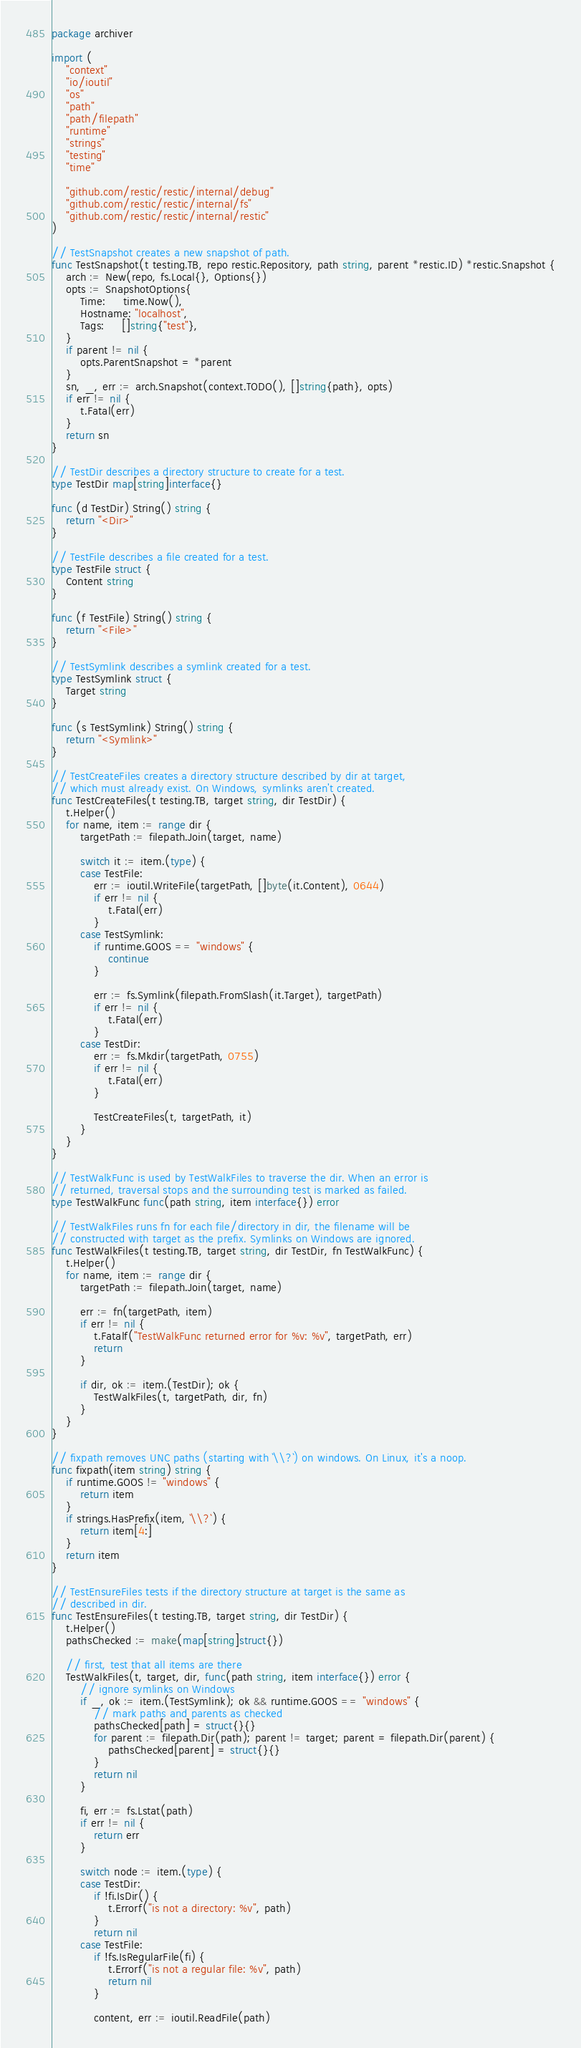<code> <loc_0><loc_0><loc_500><loc_500><_Go_>package archiver

import (
	"context"
	"io/ioutil"
	"os"
	"path"
	"path/filepath"
	"runtime"
	"strings"
	"testing"
	"time"

	"github.com/restic/restic/internal/debug"
	"github.com/restic/restic/internal/fs"
	"github.com/restic/restic/internal/restic"
)

// TestSnapshot creates a new snapshot of path.
func TestSnapshot(t testing.TB, repo restic.Repository, path string, parent *restic.ID) *restic.Snapshot {
	arch := New(repo, fs.Local{}, Options{})
	opts := SnapshotOptions{
		Time:     time.Now(),
		Hostname: "localhost",
		Tags:     []string{"test"},
	}
	if parent != nil {
		opts.ParentSnapshot = *parent
	}
	sn, _, err := arch.Snapshot(context.TODO(), []string{path}, opts)
	if err != nil {
		t.Fatal(err)
	}
	return sn
}

// TestDir describes a directory structure to create for a test.
type TestDir map[string]interface{}

func (d TestDir) String() string {
	return "<Dir>"
}

// TestFile describes a file created for a test.
type TestFile struct {
	Content string
}

func (f TestFile) String() string {
	return "<File>"
}

// TestSymlink describes a symlink created for a test.
type TestSymlink struct {
	Target string
}

func (s TestSymlink) String() string {
	return "<Symlink>"
}

// TestCreateFiles creates a directory structure described by dir at target,
// which must already exist. On Windows, symlinks aren't created.
func TestCreateFiles(t testing.TB, target string, dir TestDir) {
	t.Helper()
	for name, item := range dir {
		targetPath := filepath.Join(target, name)

		switch it := item.(type) {
		case TestFile:
			err := ioutil.WriteFile(targetPath, []byte(it.Content), 0644)
			if err != nil {
				t.Fatal(err)
			}
		case TestSymlink:
			if runtime.GOOS == "windows" {
				continue
			}

			err := fs.Symlink(filepath.FromSlash(it.Target), targetPath)
			if err != nil {
				t.Fatal(err)
			}
		case TestDir:
			err := fs.Mkdir(targetPath, 0755)
			if err != nil {
				t.Fatal(err)
			}

			TestCreateFiles(t, targetPath, it)
		}
	}
}

// TestWalkFunc is used by TestWalkFiles to traverse the dir. When an error is
// returned, traversal stops and the surrounding test is marked as failed.
type TestWalkFunc func(path string, item interface{}) error

// TestWalkFiles runs fn for each file/directory in dir, the filename will be
// constructed with target as the prefix. Symlinks on Windows are ignored.
func TestWalkFiles(t testing.TB, target string, dir TestDir, fn TestWalkFunc) {
	t.Helper()
	for name, item := range dir {
		targetPath := filepath.Join(target, name)

		err := fn(targetPath, item)
		if err != nil {
			t.Fatalf("TestWalkFunc returned error for %v: %v", targetPath, err)
			return
		}

		if dir, ok := item.(TestDir); ok {
			TestWalkFiles(t, targetPath, dir, fn)
		}
	}
}

// fixpath removes UNC paths (starting with `\\?`) on windows. On Linux, it's a noop.
func fixpath(item string) string {
	if runtime.GOOS != "windows" {
		return item
	}
	if strings.HasPrefix(item, `\\?`) {
		return item[4:]
	}
	return item
}

// TestEnsureFiles tests if the directory structure at target is the same as
// described in dir.
func TestEnsureFiles(t testing.TB, target string, dir TestDir) {
	t.Helper()
	pathsChecked := make(map[string]struct{})

	// first, test that all items are there
	TestWalkFiles(t, target, dir, func(path string, item interface{}) error {
		// ignore symlinks on Windows
		if _, ok := item.(TestSymlink); ok && runtime.GOOS == "windows" {
			// mark paths and parents as checked
			pathsChecked[path] = struct{}{}
			for parent := filepath.Dir(path); parent != target; parent = filepath.Dir(parent) {
				pathsChecked[parent] = struct{}{}
			}
			return nil
		}

		fi, err := fs.Lstat(path)
		if err != nil {
			return err
		}

		switch node := item.(type) {
		case TestDir:
			if !fi.IsDir() {
				t.Errorf("is not a directory: %v", path)
			}
			return nil
		case TestFile:
			if !fs.IsRegularFile(fi) {
				t.Errorf("is not a regular file: %v", path)
				return nil
			}

			content, err := ioutil.ReadFile(path)</code> 